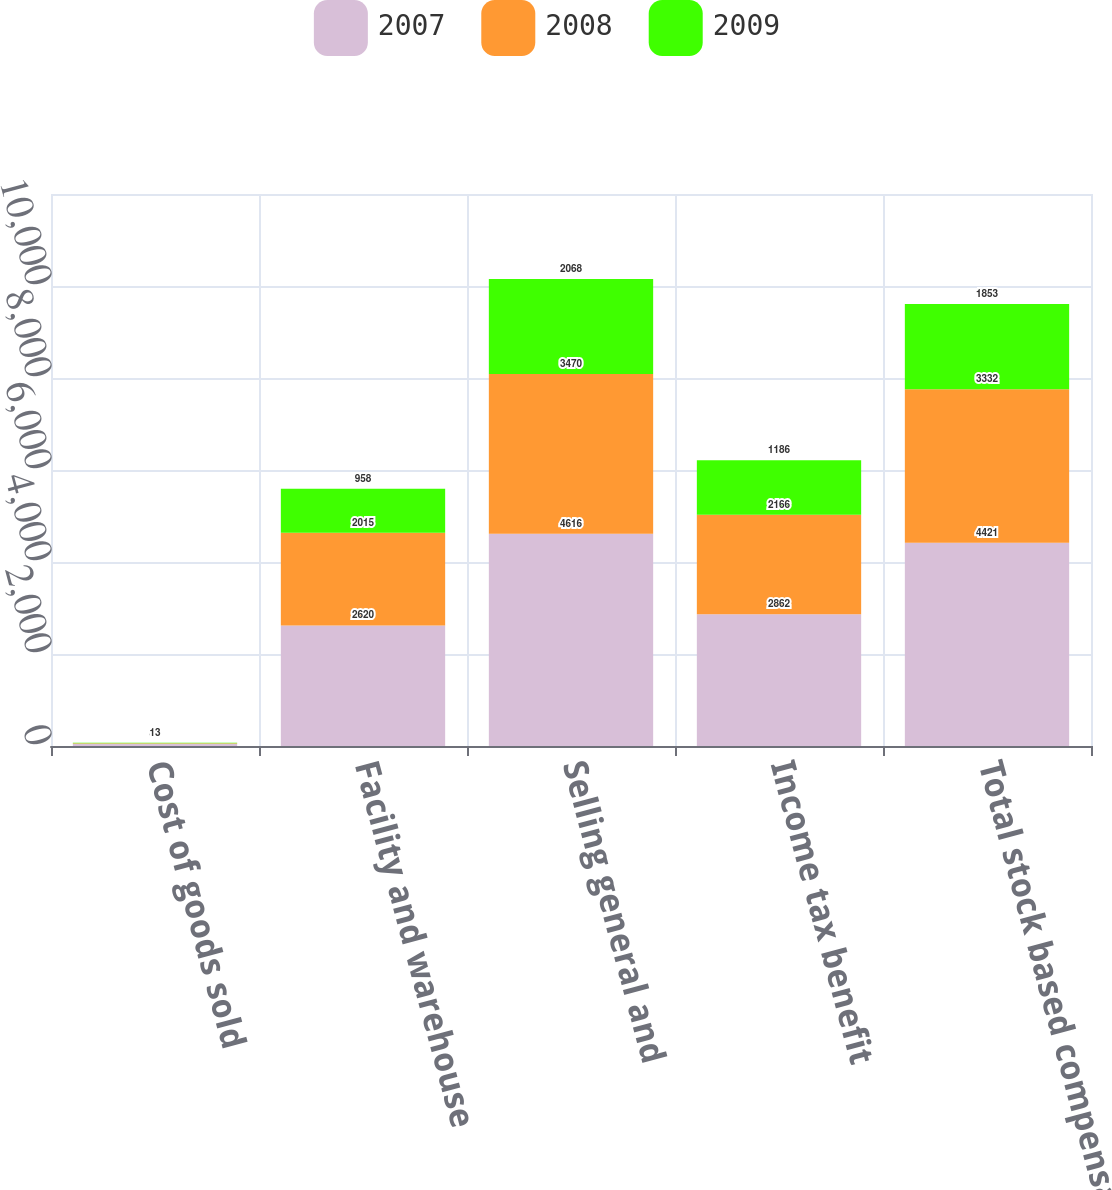Convert chart to OTSL. <chart><loc_0><loc_0><loc_500><loc_500><stacked_bar_chart><ecel><fcel>Cost of goods sold<fcel>Facility and warehouse<fcel>Selling general and<fcel>Income tax benefit<fcel>Total stock based compensation<nl><fcel>2007<fcel>47<fcel>2620<fcel>4616<fcel>2862<fcel>4421<nl><fcel>2008<fcel>13<fcel>2015<fcel>3470<fcel>2166<fcel>3332<nl><fcel>2009<fcel>13<fcel>958<fcel>2068<fcel>1186<fcel>1853<nl></chart> 